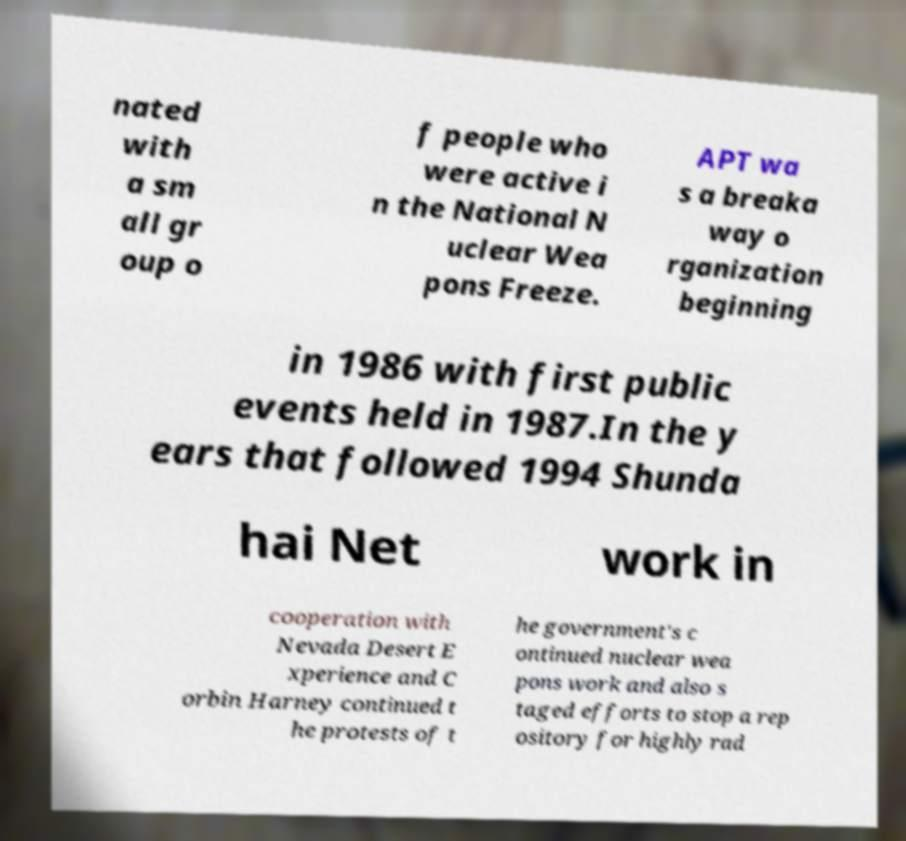What messages or text are displayed in this image? I need them in a readable, typed format. nated with a sm all gr oup o f people who were active i n the National N uclear Wea pons Freeze. APT wa s a breaka way o rganization beginning in 1986 with first public events held in 1987.In the y ears that followed 1994 Shunda hai Net work in cooperation with Nevada Desert E xperience and C orbin Harney continued t he protests of t he government's c ontinued nuclear wea pons work and also s taged efforts to stop a rep ository for highly rad 